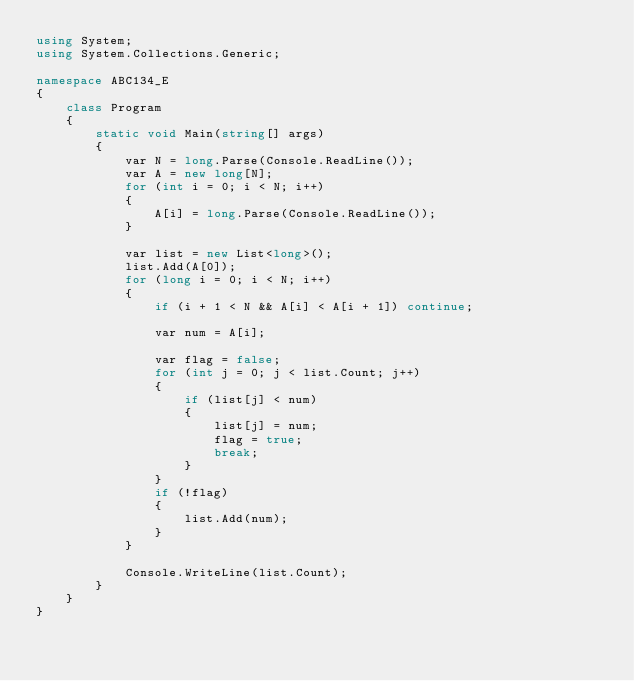<code> <loc_0><loc_0><loc_500><loc_500><_C#_>using System;
using System.Collections.Generic;

namespace ABC134_E
{
    class Program
    {
        static void Main(string[] args)
        {
            var N = long.Parse(Console.ReadLine());
            var A = new long[N];
            for (int i = 0; i < N; i++)
            {
                A[i] = long.Parse(Console.ReadLine());
            }

            var list = new List<long>();
            list.Add(A[0]);
            for (long i = 0; i < N; i++)
            {
                if (i + 1 < N && A[i] < A[i + 1]) continue;

                var num = A[i];

                var flag = false;
                for (int j = 0; j < list.Count; j++)
                {
                    if (list[j] < num)
                    {
                        list[j] = num;
                        flag = true;
                        break;
                    }
                }
                if (!flag)
                {
                    list.Add(num);
                }
            }

            Console.WriteLine(list.Count);
        }
    }
}</code> 